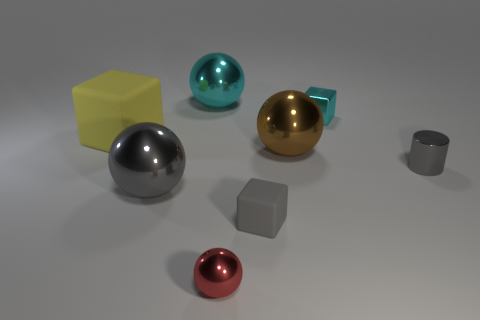Is there a brown metallic cylinder that has the same size as the gray rubber block?
Provide a succinct answer. No. What is the material of the yellow thing that is the same size as the brown metallic thing?
Your answer should be compact. Rubber. What number of objects are cyan shiny objects that are to the right of the tiny red metal sphere or cyan objects that are right of the large brown metallic sphere?
Offer a terse response. 1. Are there any small rubber objects that have the same shape as the big yellow thing?
Keep it short and to the point. Yes. There is a tiny block that is the same color as the metallic cylinder; what material is it?
Offer a very short reply. Rubber. What number of rubber objects are either cylinders or red objects?
Ensure brevity in your answer.  0. The tiny gray shiny object is what shape?
Offer a terse response. Cylinder. How many other cylinders are the same material as the cylinder?
Your answer should be very brief. 0. What is the color of the object that is made of the same material as the tiny gray block?
Your response must be concise. Yellow. There is a block behind the yellow matte cube; is its size the same as the brown thing?
Offer a very short reply. No. 